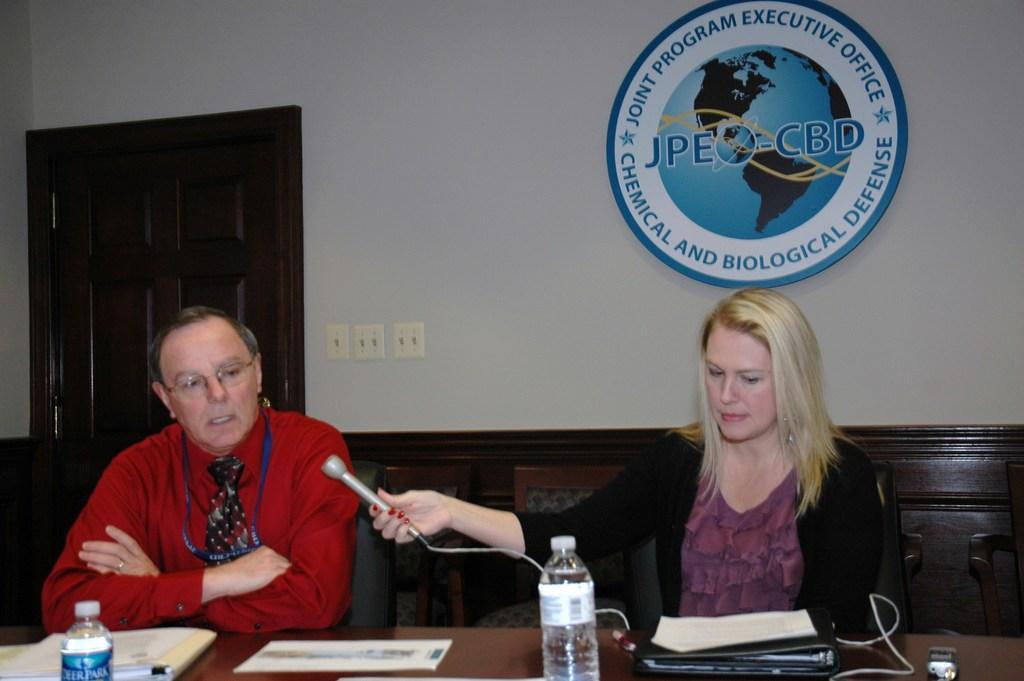Could you give a brief overview of what you see in this image? In this picture, we see the man and the women are sitting on the chairs. The woman is holding a microphone in her hand and the man is talking on the microphone. In front of them, we see a table on which files, papers, water bottles and a cable are placed. Behind them, we see a wall in white and brown color and we see the logo of the organisation is placed on the wall. On the left side, we see the brown door. 